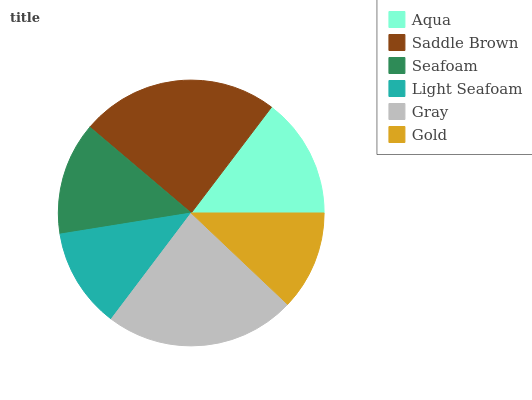Is Gold the minimum?
Answer yes or no. Yes. Is Saddle Brown the maximum?
Answer yes or no. Yes. Is Seafoam the minimum?
Answer yes or no. No. Is Seafoam the maximum?
Answer yes or no. No. Is Saddle Brown greater than Seafoam?
Answer yes or no. Yes. Is Seafoam less than Saddle Brown?
Answer yes or no. Yes. Is Seafoam greater than Saddle Brown?
Answer yes or no. No. Is Saddle Brown less than Seafoam?
Answer yes or no. No. Is Aqua the high median?
Answer yes or no. Yes. Is Seafoam the low median?
Answer yes or no. Yes. Is Gold the high median?
Answer yes or no. No. Is Gold the low median?
Answer yes or no. No. 